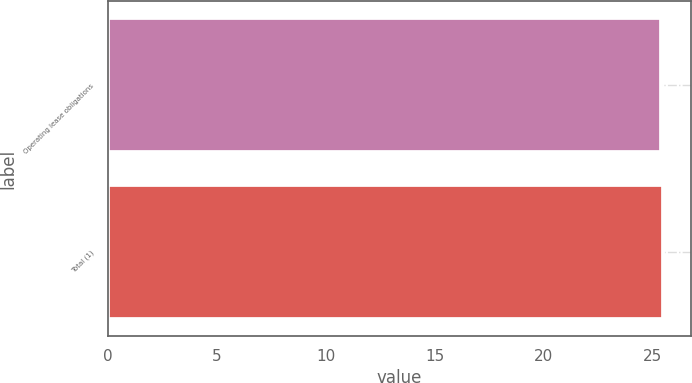Convert chart. <chart><loc_0><loc_0><loc_500><loc_500><bar_chart><fcel>Operating lease obligations<fcel>Total (1)<nl><fcel>25.4<fcel>25.5<nl></chart> 